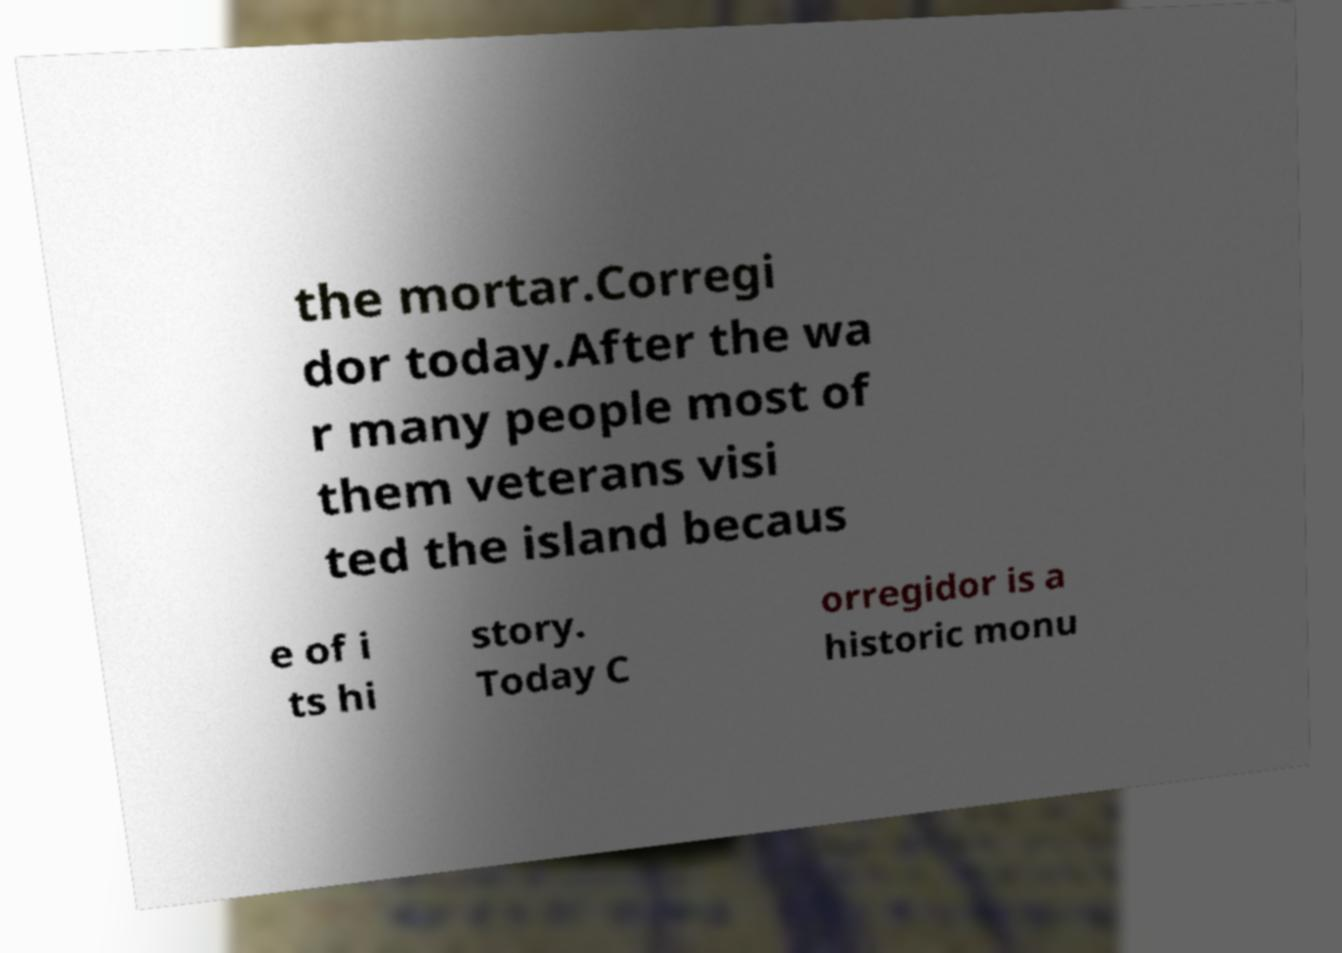Could you assist in decoding the text presented in this image and type it out clearly? the mortar.Corregi dor today.After the wa r many people most of them veterans visi ted the island becaus e of i ts hi story. Today C orregidor is a historic monu 